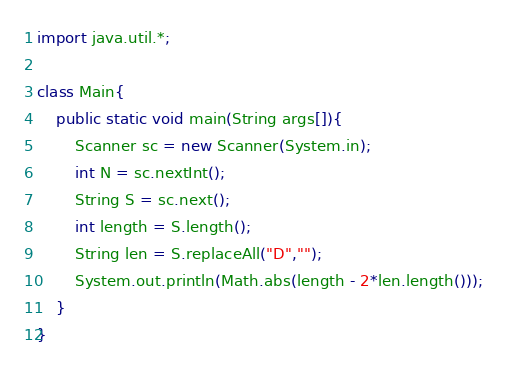<code> <loc_0><loc_0><loc_500><loc_500><_Java_>import java.util.*;

class Main{
    public static void main(String args[]){
        Scanner sc = new Scanner(System.in);
        int N = sc.nextInt();
        String S = sc.next();
        int length = S.length();
        String len = S.replaceAll("D","");
        System.out.println(Math.abs(length - 2*len.length()));
    }
}</code> 